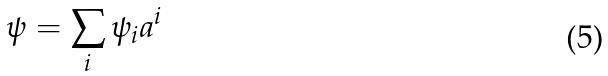Convert formula to latex. <formula><loc_0><loc_0><loc_500><loc_500>\psi = \sum _ { i } \psi _ { i } a ^ { i }</formula> 